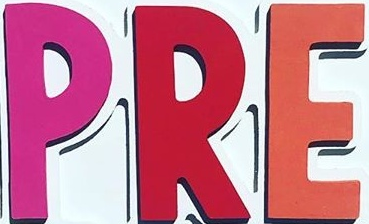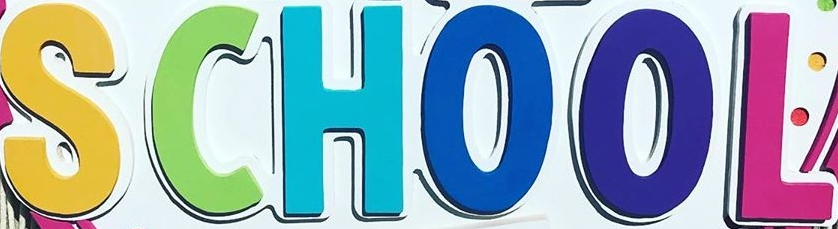Transcribe the words shown in these images in order, separated by a semicolon. PRE; SCHOOL 